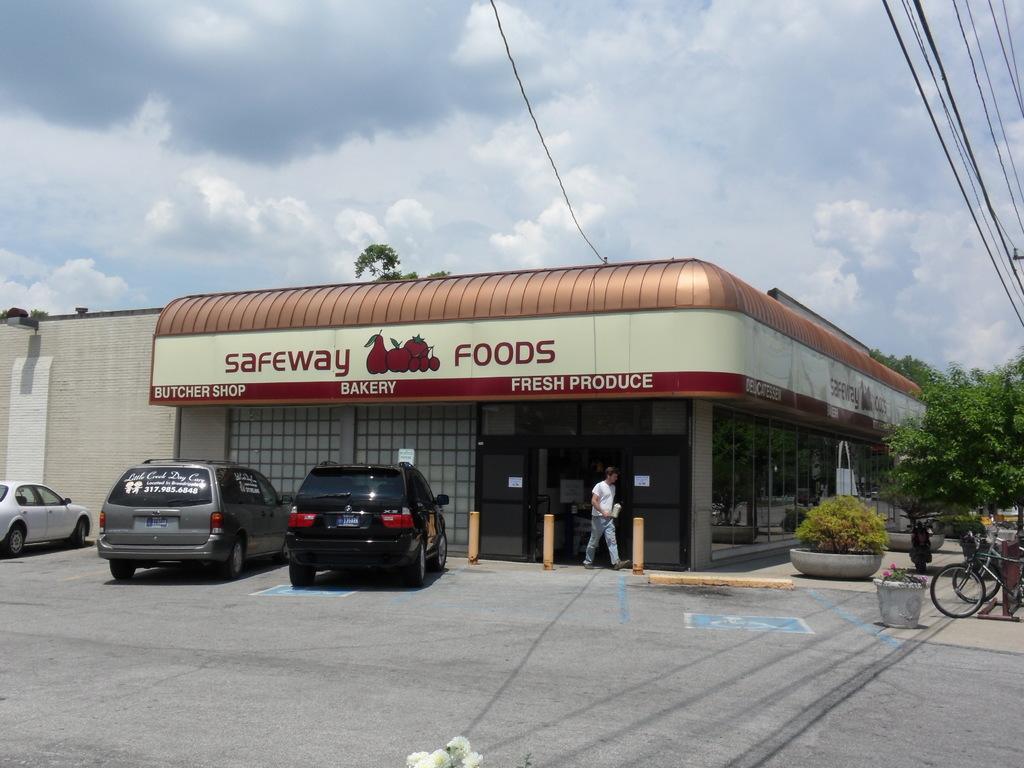Please provide a concise description of this image. In this image there is a store in the middle. On the right side there are few cycles parked on the road. On the left side there are cars parked in front of the store. At the top there is the sky. On the right side top there are wires. On the right side bottom there are trees on the footpath. 